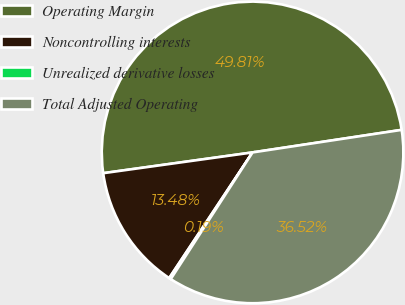<chart> <loc_0><loc_0><loc_500><loc_500><pie_chart><fcel>Operating Margin<fcel>Noncontrolling interests<fcel>Unrealized derivative losses<fcel>Total Adjusted Operating<nl><fcel>49.81%<fcel>13.48%<fcel>0.19%<fcel>36.52%<nl></chart> 